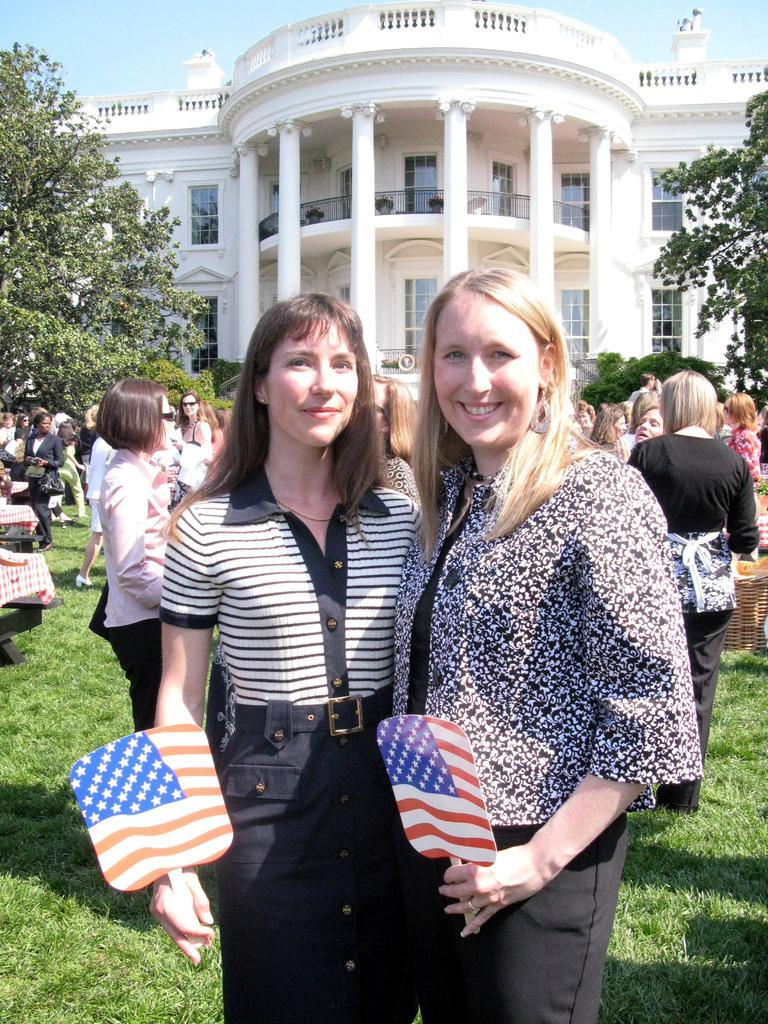Can you describe this image briefly? In this image we can see two women are smiling and they are holding flags with their hands. Here we can see grass, people, tablecloths, plants, and trees. In the background we can see a building and sky. 